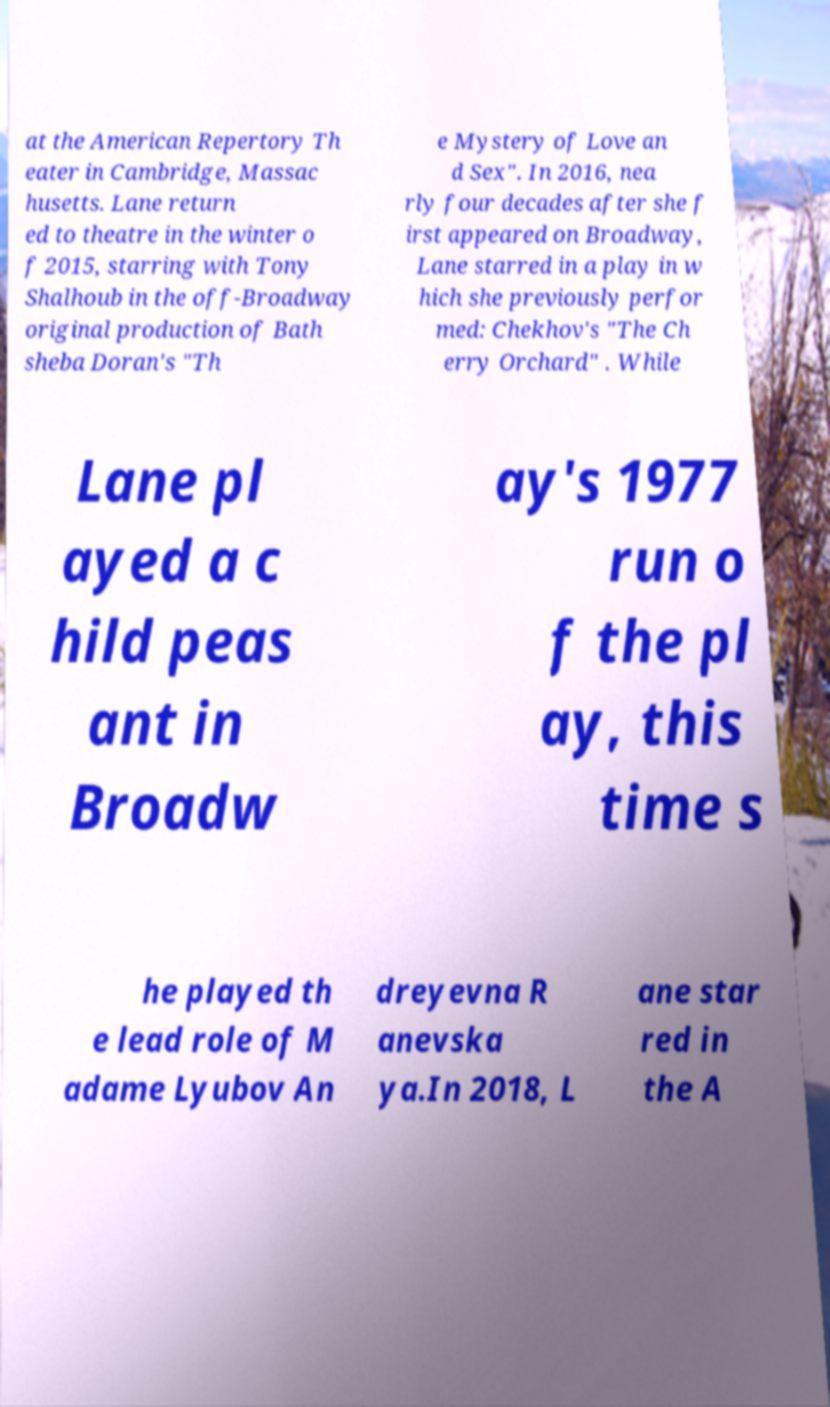There's text embedded in this image that I need extracted. Can you transcribe it verbatim? at the American Repertory Th eater in Cambridge, Massac husetts. Lane return ed to theatre in the winter o f 2015, starring with Tony Shalhoub in the off-Broadway original production of Bath sheba Doran's "Th e Mystery of Love an d Sex". In 2016, nea rly four decades after she f irst appeared on Broadway, Lane starred in a play in w hich she previously perfor med: Chekhov's "The Ch erry Orchard" . While Lane pl ayed a c hild peas ant in Broadw ay's 1977 run o f the pl ay, this time s he played th e lead role of M adame Lyubov An dreyevna R anevska ya.In 2018, L ane star red in the A 